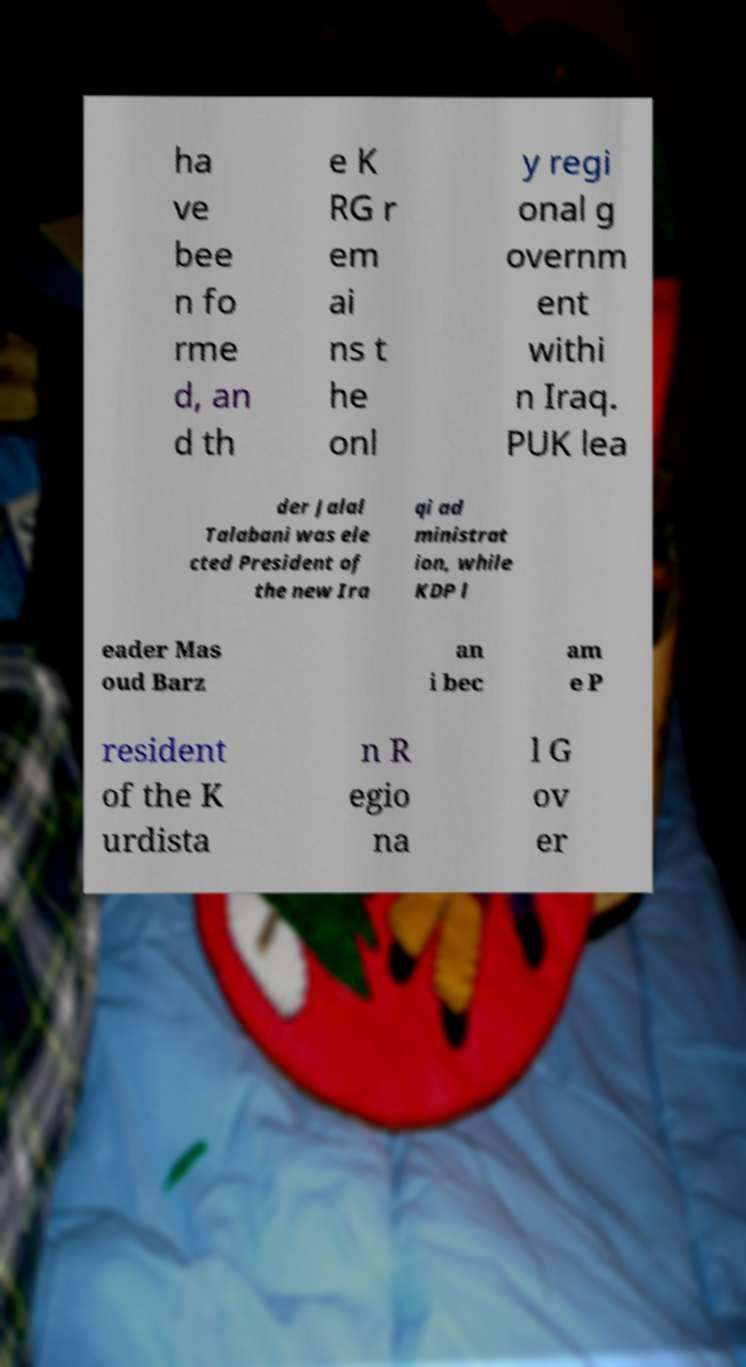Can you read and provide the text displayed in the image?This photo seems to have some interesting text. Can you extract and type it out for me? ha ve bee n fo rme d, an d th e K RG r em ai ns t he onl y regi onal g overnm ent withi n Iraq. PUK lea der Jalal Talabani was ele cted President of the new Ira qi ad ministrat ion, while KDP l eader Mas oud Barz an i bec am e P resident of the K urdista n R egio na l G ov er 